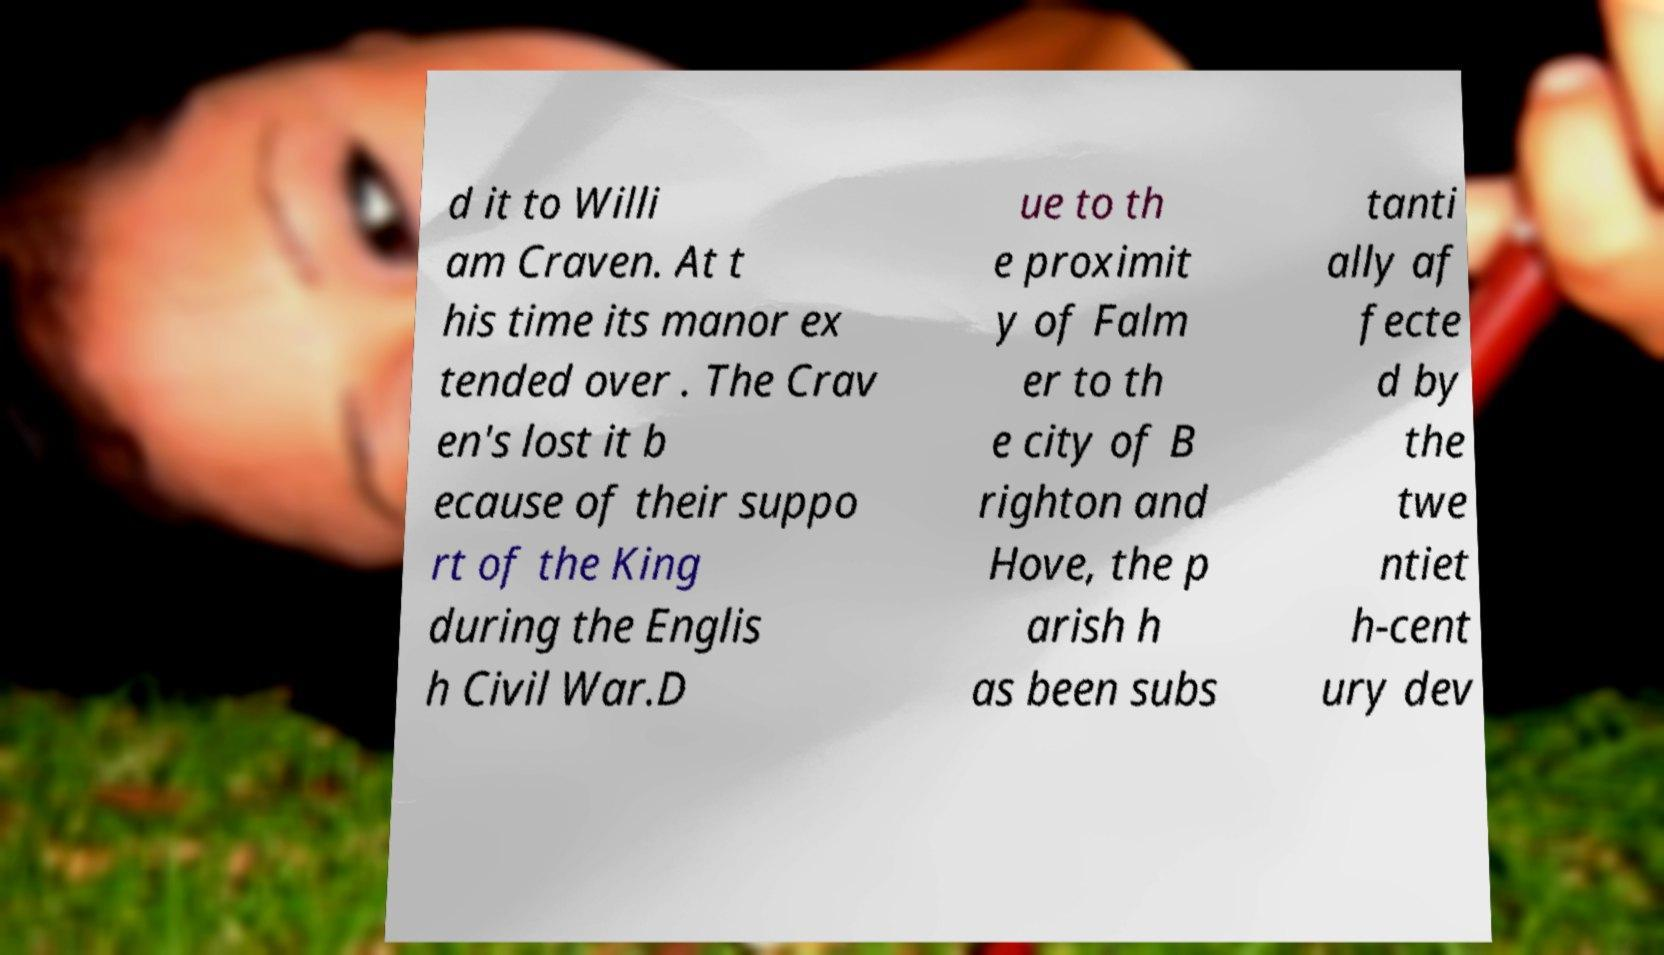Could you extract and type out the text from this image? d it to Willi am Craven. At t his time its manor ex tended over . The Crav en's lost it b ecause of their suppo rt of the King during the Englis h Civil War.D ue to th e proximit y of Falm er to th e city of B righton and Hove, the p arish h as been subs tanti ally af fecte d by the twe ntiet h-cent ury dev 